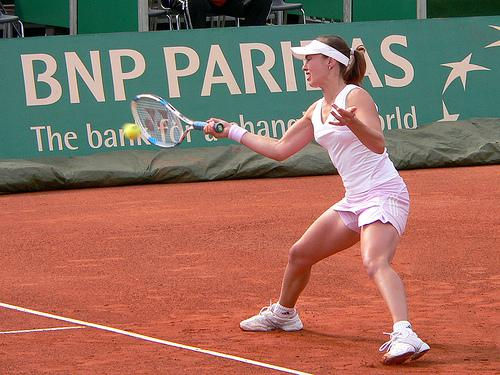Question: where was this photo taken?
Choices:
A. Forest.
B. Street.
C. City.
D. Tennis court.
Answer with the letter. Answer: D Question: what sport is this girl playing?
Choices:
A. Volleyball.
B. Baseball.
C. Soccer.
D. Tennis.
Answer with the letter. Answer: D Question: how many players are in the photo?
Choices:
A. Two.
B. Three.
C. Four.
D. One.
Answer with the letter. Answer: D Question: what color outfit is the lady wearing?
Choices:
A. Black.
B. Blue.
C. Red.
D. White.
Answer with the letter. Answer: D Question: what type of shoes is this lady wearing?
Choices:
A. Sneakers.
B. High heels.
C. Sandals.
D. Dress shoes.
Answer with the letter. Answer: A Question: what hand is the lady holding the racket?
Choices:
A. Right hand.
B. Left hand.
C. Middle Hand.
D. Front hand.
Answer with the letter. Answer: A 